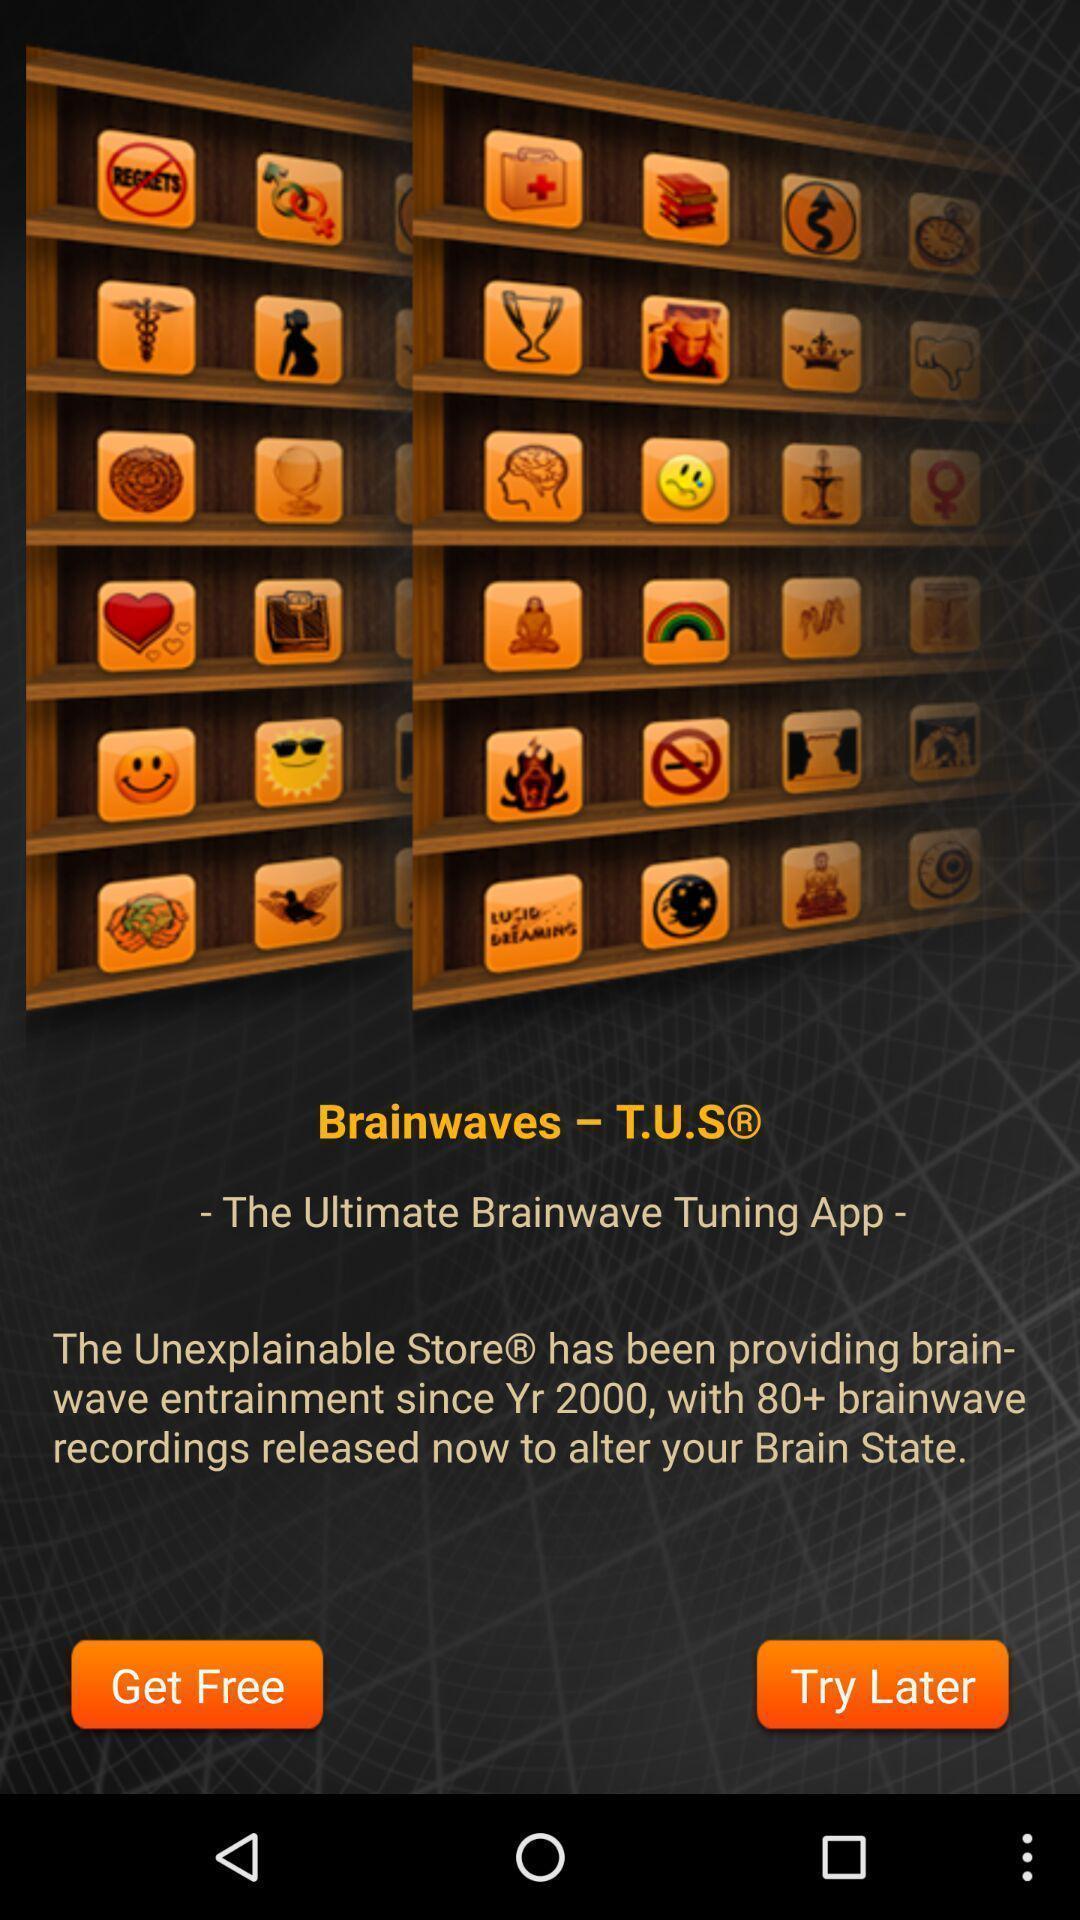Tell me about the visual elements in this screen capture. Window displaying a brain games. 